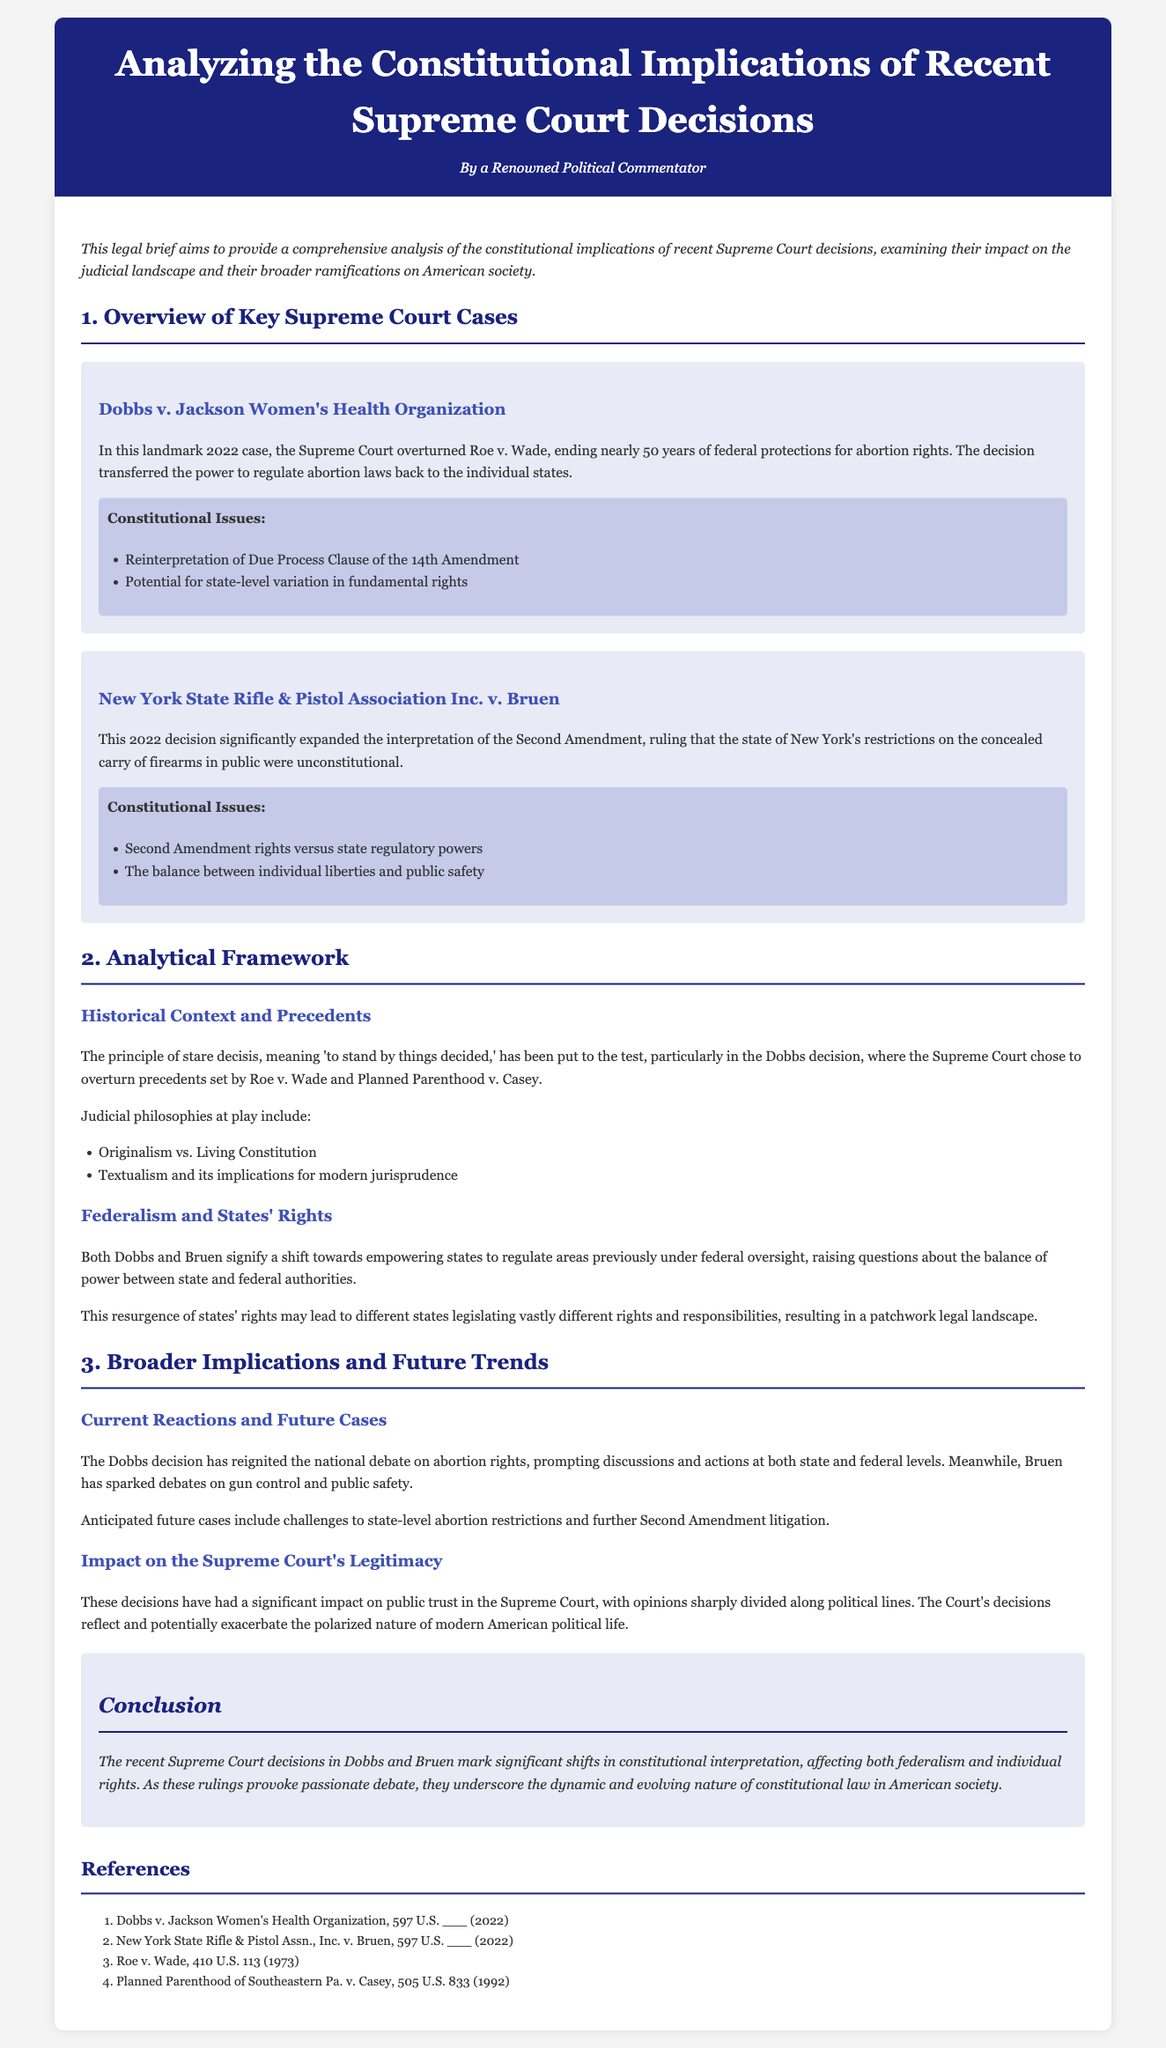What was the landmark case that overturned Roe v. Wade? The document states that the landmark case which overturned Roe v. Wade is Dobbs v. Jackson Women's Health Organization.
Answer: Dobbs v. Jackson Women's Health Organization What year was the Dobbs decision made? According to the text, the Dobbs decision was made in 2022.
Answer: 2022 What constitutional amendment is primarily referenced in the case of New York State Rifle & Pistol Association Inc. v. Bruen? The document highlights the Second Amendment as the primary constitutional amendment in the Bruen case.
Answer: Second Amendment What principle does "stare decisis" refer to in legal contexts? The document explains that "stare decisis" means to 'stand by things decided.'
Answer: 'stand by things decided' What are the two judicial philosophies mentioned in the text? The two judicial philosophies discussed in the document are Originalism and Living Constitution.
Answer: Originalism and Living Constitution What potential effect do the Dobbs and Bruen decisions have on state laws? The document notes that these decisions empower states to regulate areas previously under federal oversight, leading to a patchwork legal landscape.
Answer: Empower states to regulate What significant impact do these recent Supreme Court decisions have on public opinion? According to the text, the decisions have significantly impacted public trust in the Supreme Court, leading to opinions sharply divided along political lines.
Answer: Public trust What future legal challenges does the document anticipate following the Dobbs decision? The text anticipates challenges to state-level abortion restrictions as a result of the Dobbs decision.
Answer: Challenges to state-level abortion restrictions What is a potential future litigation topic mentioned in conjunction with Bruen? The document mentions further Second Amendment litigation as a potential future topic of litigation.
Answer: Further Second Amendment litigation 